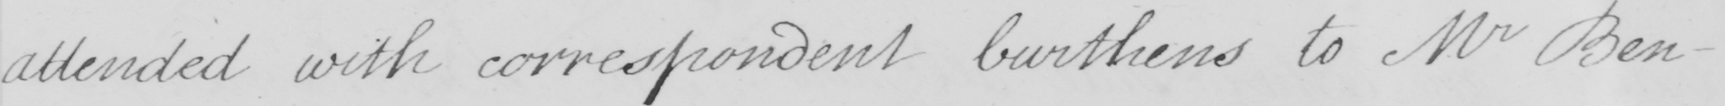What does this handwritten line say? attended with correspondent burthens to Mr Ben- 